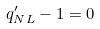<formula> <loc_0><loc_0><loc_500><loc_500>q ^ { \prime } _ { N L } - 1 = 0</formula> 